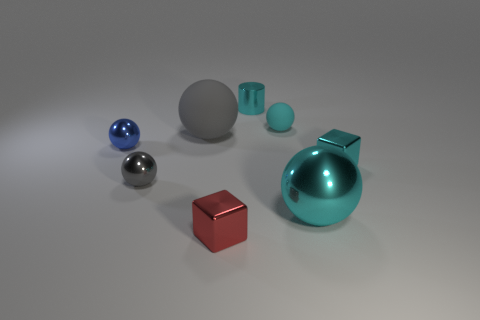What material is the large gray ball?
Your answer should be very brief. Rubber. There is a small shiny ball in front of the small blue sphere that is behind the gray ball in front of the cyan shiny block; what color is it?
Give a very brief answer. Gray. How many red cubes have the same size as the gray shiny ball?
Your answer should be very brief. 1. There is a large object left of the tiny cyan matte sphere; what color is it?
Ensure brevity in your answer.  Gray. How many other things are the same size as the metallic cylinder?
Offer a very short reply. 5. What size is the ball that is both to the right of the red thing and in front of the big gray ball?
Provide a succinct answer. Large. There is a large rubber sphere; is its color the same as the small metal cube left of the tiny shiny cylinder?
Keep it short and to the point. No. Are there any small cyan metallic things of the same shape as the tiny blue shiny object?
Provide a short and direct response. No. How many objects are large purple cylinders or cyan rubber things that are behind the blue metal sphere?
Ensure brevity in your answer.  1. How many other objects are there of the same material as the small cylinder?
Your answer should be compact. 5. 